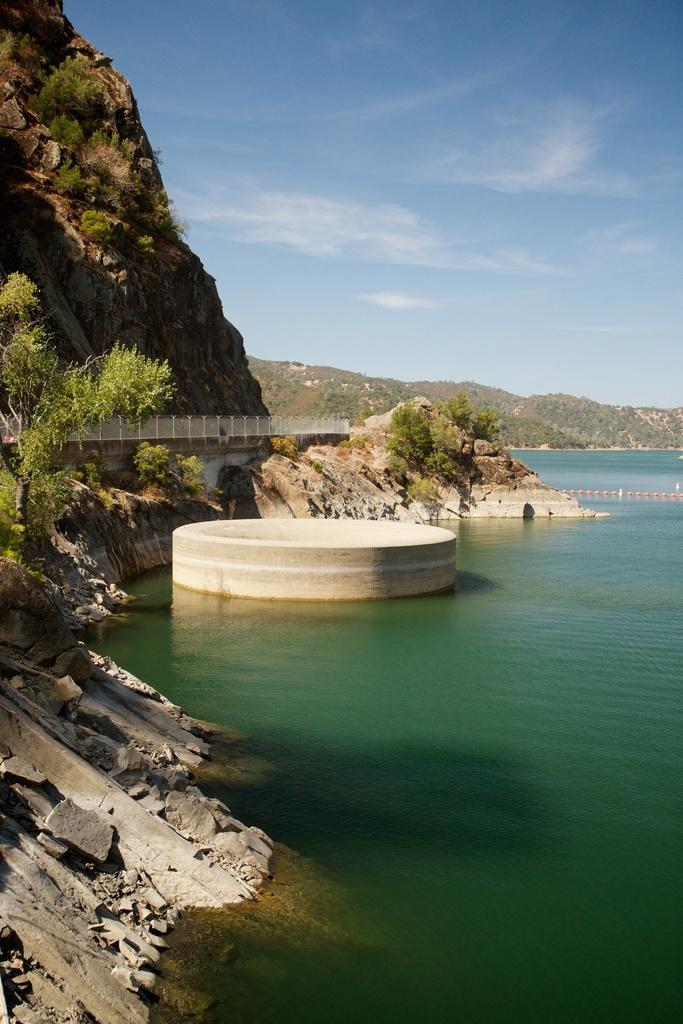Can you describe this image briefly? In this image I can see the water surface. I can see mountains. I can see few trees. At the top I can see clouds in the sky. 